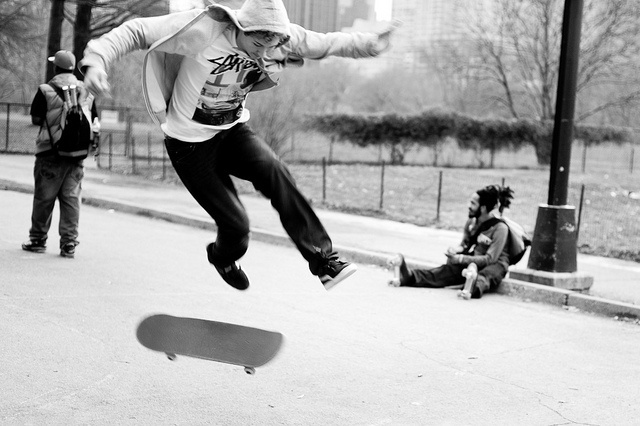Describe the objects in this image and their specific colors. I can see people in gray, black, gainsboro, and darkgray tones, people in gray, black, darkgray, and lightgray tones, people in gray, black, darkgray, and lightgray tones, skateboard in gray and lightgray tones, and backpack in gray, black, darkgray, and lightgray tones in this image. 